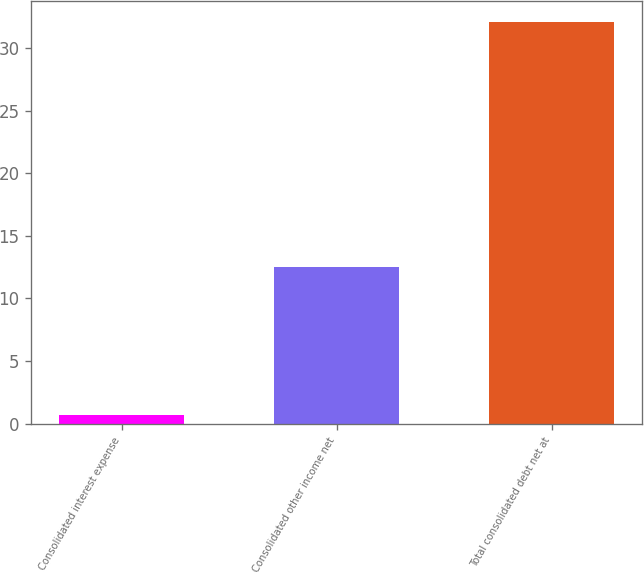<chart> <loc_0><loc_0><loc_500><loc_500><bar_chart><fcel>Consolidated interest expense<fcel>Consolidated other income net<fcel>Total consolidated debt net at<nl><fcel>0.7<fcel>12.5<fcel>32.1<nl></chart> 